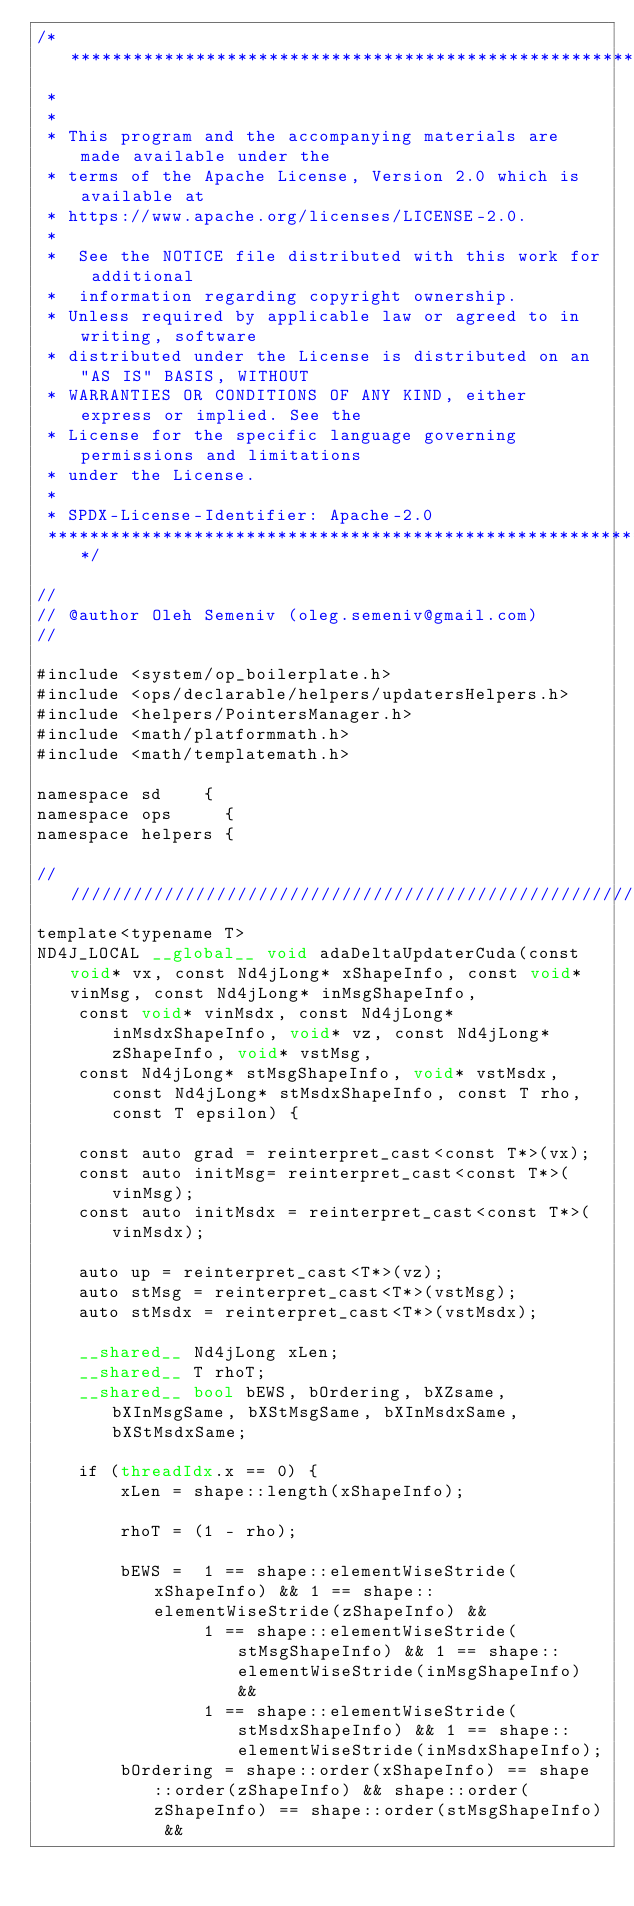<code> <loc_0><loc_0><loc_500><loc_500><_Cuda_>/* ******************************************************************************
 *
 *
 * This program and the accompanying materials are made available under the
 * terms of the Apache License, Version 2.0 which is available at
 * https://www.apache.org/licenses/LICENSE-2.0.
 *
 *  See the NOTICE file distributed with this work for additional
 *  information regarding copyright ownership.
 * Unless required by applicable law or agreed to in writing, software
 * distributed under the License is distributed on an "AS IS" BASIS, WITHOUT
 * WARRANTIES OR CONDITIONS OF ANY KIND, either express or implied. See the
 * License for the specific language governing permissions and limitations
 * under the License.
 *
 * SPDX-License-Identifier: Apache-2.0
 ******************************************************************************/

//
// @author Oleh Semeniv (oleg.semeniv@gmail.com)
//

#include <system/op_boilerplate.h>
#include <ops/declarable/helpers/updatersHelpers.h>
#include <helpers/PointersManager.h>
#include <math/platformmath.h>
#include <math/templatemath.h>

namespace sd    {
namespace ops     {
namespace helpers {

///////////////////////////////////////////////////////////////////
template<typename T>
ND4J_LOCAL __global__ void adaDeltaUpdaterCuda(const void* vx, const Nd4jLong* xShapeInfo, const void* vinMsg, const Nd4jLong* inMsgShapeInfo, 
    const void* vinMsdx, const Nd4jLong* inMsdxShapeInfo, void* vz, const Nd4jLong* zShapeInfo, void* vstMsg, 
    const Nd4jLong* stMsgShapeInfo, void* vstMsdx, const Nd4jLong* stMsdxShapeInfo, const T rho, const T epsilon) {

    const auto grad = reinterpret_cast<const T*>(vx);
    const auto initMsg= reinterpret_cast<const T*>(vinMsg);
    const auto initMsdx = reinterpret_cast<const T*>(vinMsdx);
   
    auto up = reinterpret_cast<T*>(vz);
    auto stMsg = reinterpret_cast<T*>(vstMsg);
    auto stMsdx = reinterpret_cast<T*>(vstMsdx);

    __shared__ Nd4jLong xLen;
    __shared__ T rhoT;
    __shared__ bool bEWS, bOrdering, bXZsame, bXInMsgSame, bXStMsgSame, bXInMsdxSame, bXStMsdxSame;

    if (threadIdx.x == 0) {
        xLen = shape::length(xShapeInfo);
        
        rhoT = (1 - rho);

        bEWS =  1 == shape::elementWiseStride(xShapeInfo) && 1 == shape::elementWiseStride(zShapeInfo) &&
                1 == shape::elementWiseStride(stMsgShapeInfo) && 1 == shape::elementWiseStride(inMsgShapeInfo) &&
                1 == shape::elementWiseStride(stMsdxShapeInfo) && 1 == shape::elementWiseStride(inMsdxShapeInfo);
        bOrdering = shape::order(xShapeInfo) == shape::order(zShapeInfo) && shape::order(zShapeInfo) == shape::order(stMsgShapeInfo) && </code> 